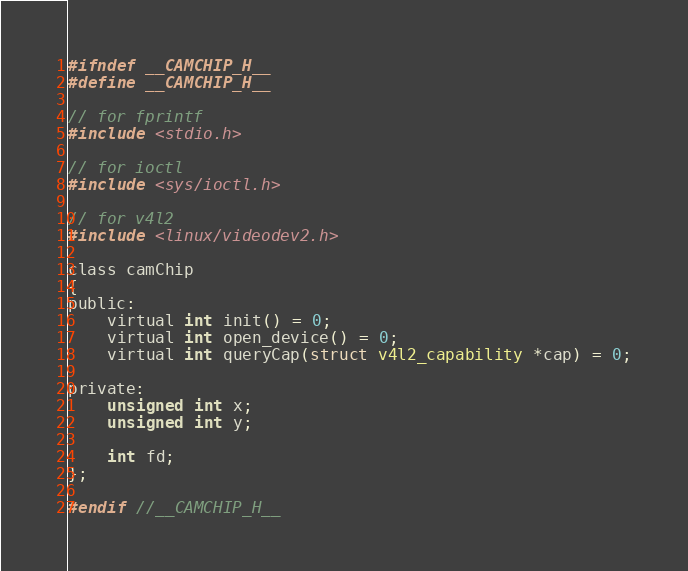<code> <loc_0><loc_0><loc_500><loc_500><_C_>#ifndef __CAMCHIP_H__
#define __CAMCHIP_H__

// for fprintf
#include <stdio.h>

// for ioctl
#include <sys/ioctl.h>

// for v4l2
#include <linux/videodev2.h>

class camChip
{
public:
	virtual int init() = 0;
	virtual int open_device() = 0;
	virtual int queryCap(struct v4l2_capability *cap) = 0;

private:
	unsigned int x;
	unsigned int y;

	int fd;
};

#endif //__CAMCHIP_H__
</code> 